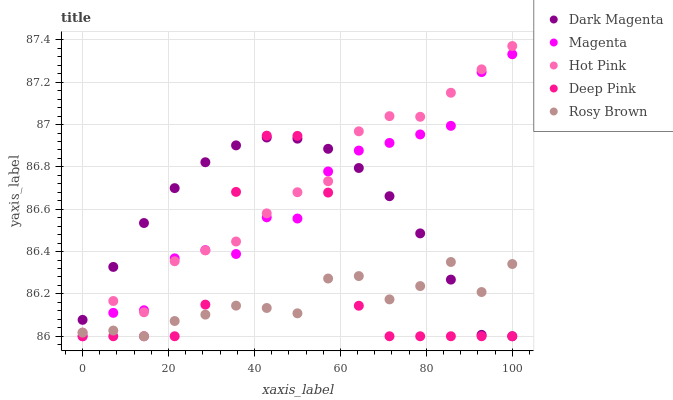Does Rosy Brown have the minimum area under the curve?
Answer yes or no. Yes. Does Hot Pink have the maximum area under the curve?
Answer yes or no. Yes. Does Hot Pink have the minimum area under the curve?
Answer yes or no. No. Does Rosy Brown have the maximum area under the curve?
Answer yes or no. No. Is Dark Magenta the smoothest?
Answer yes or no. Yes. Is Deep Pink the roughest?
Answer yes or no. Yes. Is Hot Pink the smoothest?
Answer yes or no. No. Is Hot Pink the roughest?
Answer yes or no. No. Does Magenta have the lowest value?
Answer yes or no. Yes. Does Hot Pink have the lowest value?
Answer yes or no. No. Does Hot Pink have the highest value?
Answer yes or no. Yes. Does Rosy Brown have the highest value?
Answer yes or no. No. Is Rosy Brown less than Hot Pink?
Answer yes or no. Yes. Is Hot Pink greater than Rosy Brown?
Answer yes or no. Yes. Does Dark Magenta intersect Deep Pink?
Answer yes or no. Yes. Is Dark Magenta less than Deep Pink?
Answer yes or no. No. Is Dark Magenta greater than Deep Pink?
Answer yes or no. No. Does Rosy Brown intersect Hot Pink?
Answer yes or no. No. 